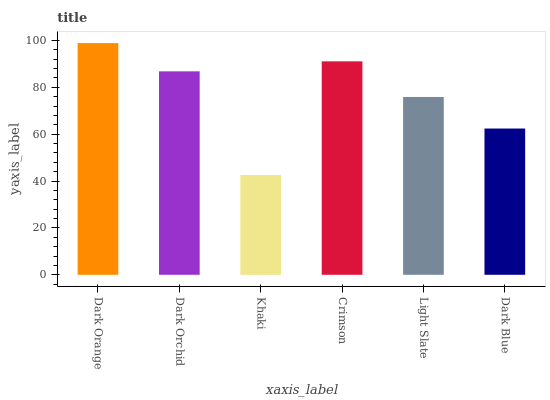Is Khaki the minimum?
Answer yes or no. Yes. Is Dark Orange the maximum?
Answer yes or no. Yes. Is Dark Orchid the minimum?
Answer yes or no. No. Is Dark Orchid the maximum?
Answer yes or no. No. Is Dark Orange greater than Dark Orchid?
Answer yes or no. Yes. Is Dark Orchid less than Dark Orange?
Answer yes or no. Yes. Is Dark Orchid greater than Dark Orange?
Answer yes or no. No. Is Dark Orange less than Dark Orchid?
Answer yes or no. No. Is Dark Orchid the high median?
Answer yes or no. Yes. Is Light Slate the low median?
Answer yes or no. Yes. Is Crimson the high median?
Answer yes or no. No. Is Khaki the low median?
Answer yes or no. No. 